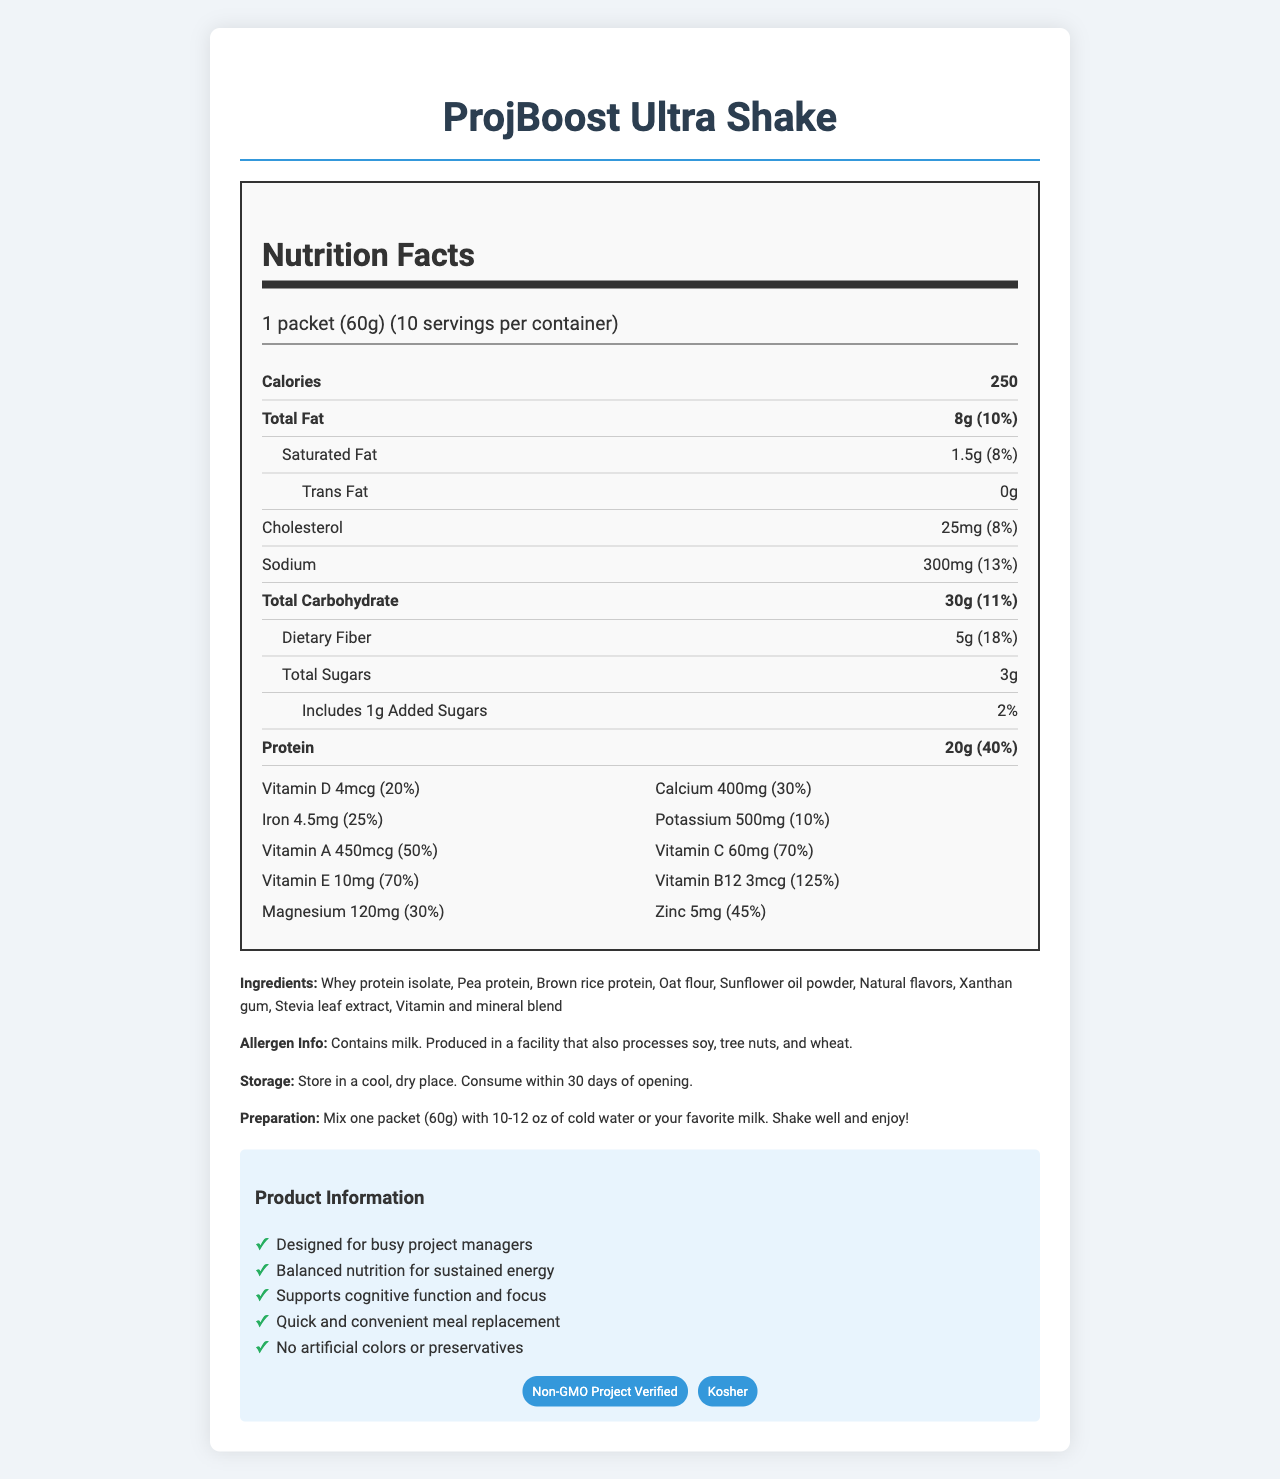What is the serving size of ProjBoost Ultra Shake? The serving size is listed as "1 packet (60g)" in the nutrition facts section.
Answer: 1 packet (60g) How many servings are there in one container? The document states there are 10 servings per container.
Answer: 10 What is the amount of protein per serving? The protein amount per serving is listed as "20g."
Answer: 20g Does the product contain added sugars? The nutrition facts indicate it includes "1g" of added sugars.
Answer: Yes What are the main ingredients of ProjBoost Ultra Shake? These ingredients are listed under the "Ingredients" section.
Answer: Whey protein isolate, Pea protein, Brown rice protein, Oat flour, Sunflower oil powder, Natural flavors, Xanthan gum, Stevia leaf extract, and Vitamin and mineral blend What percentage of the daily value of Vitamin C does one serving of the shake provide? A. 20% B. 30% C. 50% D. 70% The percentage of the daily value of Vitamin C is listed as "70%" in the vitamins section.
Answer: D. 70% Which of the following vitamins and minerals is present in the highest daily value percentage per serving? A. Vitamin D B. Calcium C. Vitamin B12 D. Magnesium The daily value percentage for Vitamin B12 is "125%", which is the highest among the listed options.
Answer: C. Vitamin B12 Is the product GMO-free? The product has the "Non-GMO Project Verified" certification which confirms it's GMO-free.
Answer: Yes Summarize the product information and main claims of ProjBoost Ultra Shake. This summary highlights the product's purpose, nutritional content, primary benefits, and certifications.
Answer: ProjBoost Ultra Shake is a meal replacement designed for busy project managers. It offers balanced nutrition for sustained energy, supports cognitive function and focus, and is quick and convenient. The shake contains 250 calories per serving, is rich in protein (20g), and includes a range of vitamins and minerals. It holds certifications like Non-GMO Project Verified and Kosher. It contains no artificial colors or preservatives. What is the source of sweetness in the shake? Stevia leaf extract is mentioned as one of the ingredients, implying it's the source of sweetness.
Answer: Stevia leaf extract How should the shake be stored? The storage instructions specify to store the product in a cool, dry place and consume it within 30 days of opening.
Answer: Store in a cool, dry place. Consume within 30 days of opening. What specific health benefit does the product claim to provide for busy project managers? The document claims that the shake "supports cognitive function and focus."
Answer: Supports cognitive function and focus What certifications does ProjBoost Ultra Shake have? These certifications are listed in the "certifications" section of the document.
Answer: Non-GMO Project Verified and Kosher Is this product suitable for someone with a tree nut allergy? The product is produced in a facility that also processes tree nuts, but it does not explicitly state it contains tree nuts.
Answer: Not enough information How much dietary fiber is in one serving of the shake? The amount of dietary fiber per serving is listed as "5g" in the nutrition facts section.
Answer: 5g Does the product contain any artificial colors or preservatives? One of the product claims is that it contains "No artificial colors or preservatives."
Answer: No 